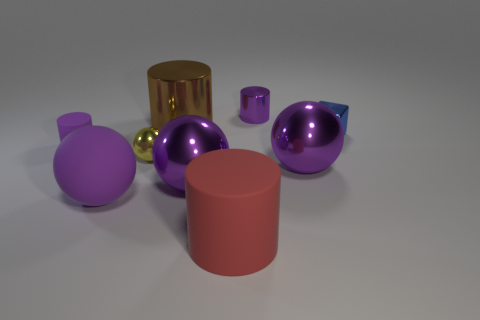Are there more small purple metal things that are left of the small blue thing than yellow matte cylinders? Upon reviewing the image, it appears that there are a total of two small purple metal objects to the left of the small blue item, whereas there is only one yellow matte cylinder present. Thus, the answer is yes, there are indeed more small purple metal things located to the left of the small blue item than there are yellow matte cylinders in the scene. 